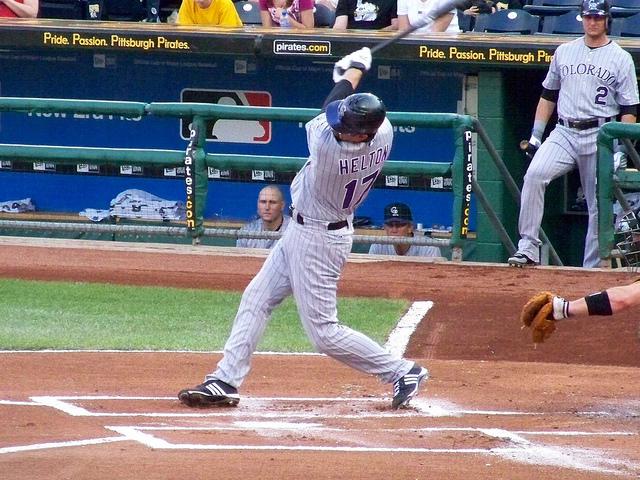Where is the batter?
Be succinct. Home plate. What sport is this?
Answer briefly. Baseball. Is the batter left handed?
Quick response, please. Yes. What is this man trying to hit?
Give a very brief answer. Baseball. 